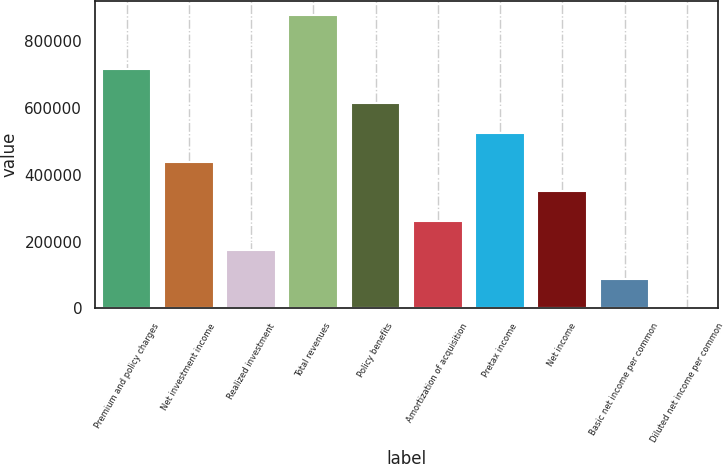<chart> <loc_0><loc_0><loc_500><loc_500><bar_chart><fcel>Premium and policy charges<fcel>Net investment income<fcel>Realized investment<fcel>Total revenues<fcel>Policy benefits<fcel>Amortization of acquisition<fcel>Pretax income<fcel>Net income<fcel>Basic net income per common<fcel>Diluted net income per common<nl><fcel>715397<fcel>438285<fcel>175315<fcel>876569<fcel>613599<fcel>262972<fcel>525942<fcel>350628<fcel>87658.1<fcel>1.32<nl></chart> 